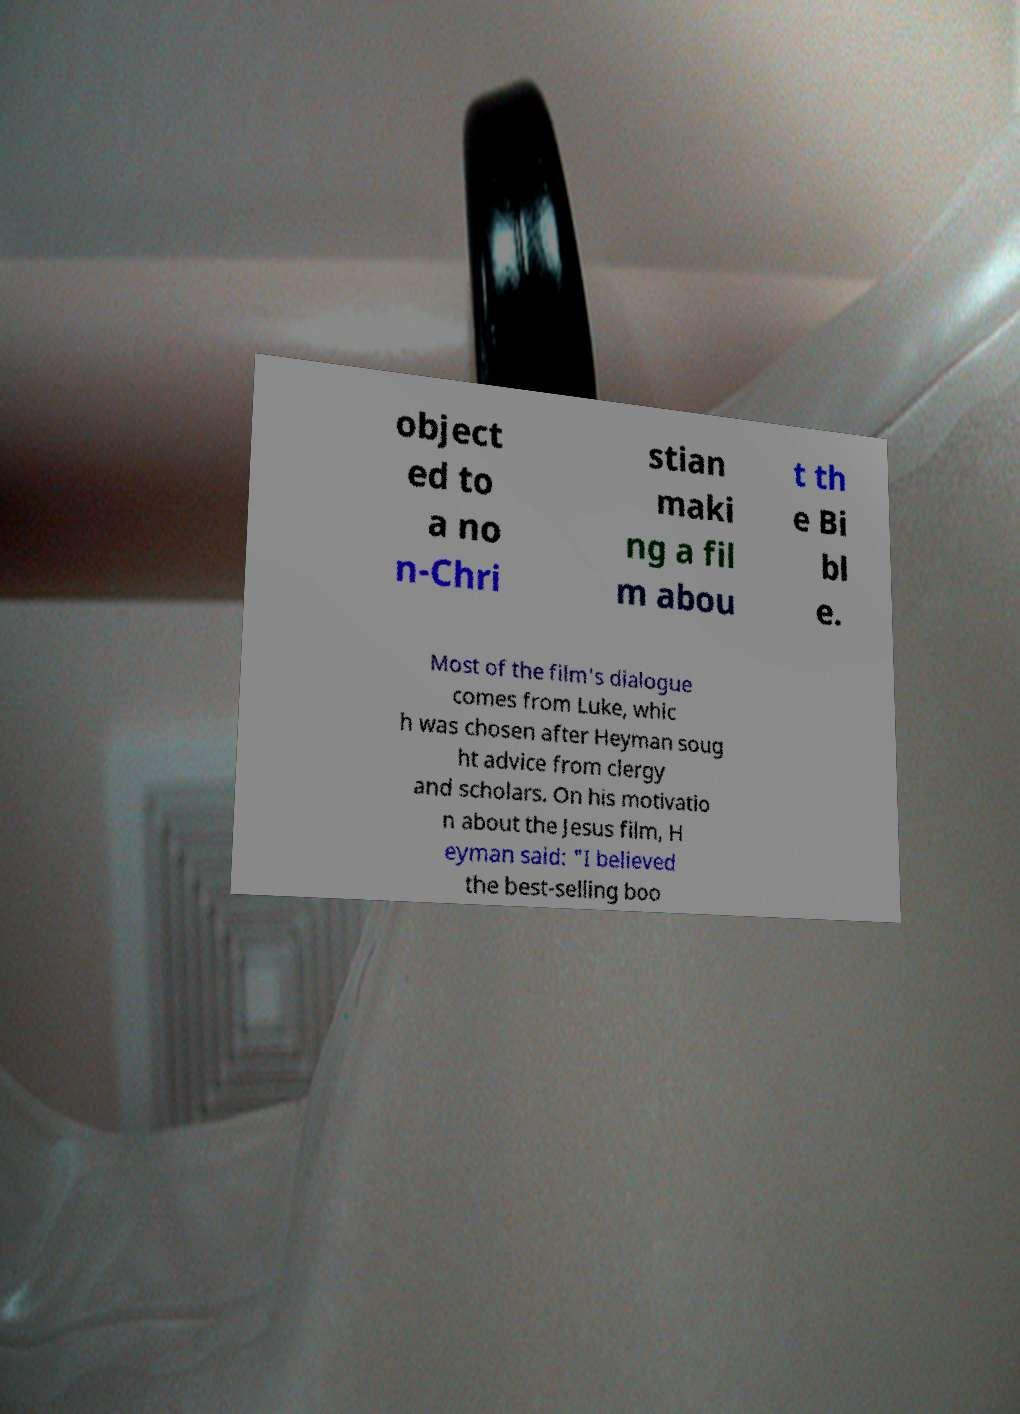There's text embedded in this image that I need extracted. Can you transcribe it verbatim? object ed to a no n-Chri stian maki ng a fil m abou t th e Bi bl e. Most of the film's dialogue comes from Luke, whic h was chosen after Heyman soug ht advice from clergy and scholars. On his motivatio n about the Jesus film, H eyman said: "I believed the best-selling boo 